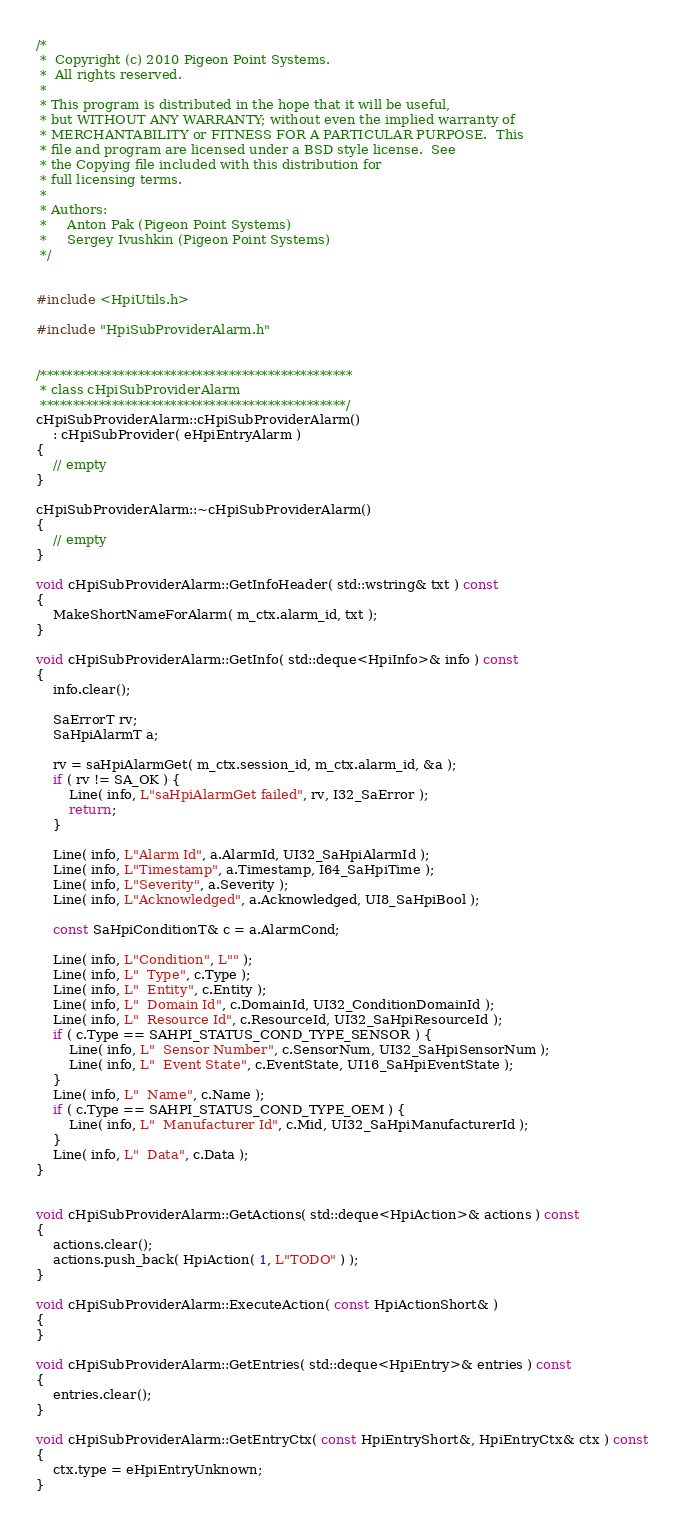<code> <loc_0><loc_0><loc_500><loc_500><_C++_>/*
 *  Copyright (c) 2010 Pigeon Point Systems.
 *  All rights reserved.
 *
 * This program is distributed in the hope that it will be useful,
 * but WITHOUT ANY WARRANTY; without even the implied warranty of
 * MERCHANTABILITY or FITNESS FOR A PARTICULAR PURPOSE.  This
 * file and program are licensed under a BSD style license.  See
 * the Copying file included with this distribution for
 * full licensing terms.
 *
 * Authors:
 *     Anton Pak (Pigeon Point Systems)
 *     Sergey Ivushkin (Pigeon Point Systems)
 */


#include <HpiUtils.h>

#include "HpiSubProviderAlarm.h"


/************************************************
 * class cHpiSubProviderAlarm
 ***********************************************/
cHpiSubProviderAlarm::cHpiSubProviderAlarm()
    : cHpiSubProvider( eHpiEntryAlarm )
{
    // empty
}

cHpiSubProviderAlarm::~cHpiSubProviderAlarm()
{
    // empty
}

void cHpiSubProviderAlarm::GetInfoHeader( std::wstring& txt ) const
{
    MakeShortNameForAlarm( m_ctx.alarm_id, txt );
}

void cHpiSubProviderAlarm::GetInfo( std::deque<HpiInfo>& info ) const
{
    info.clear();

    SaErrorT rv;
    SaHpiAlarmT a;

    rv = saHpiAlarmGet( m_ctx.session_id, m_ctx.alarm_id, &a );
    if ( rv != SA_OK ) {
        Line( info, L"saHpiAlarmGet failed", rv, I32_SaError );
        return;
    }

    Line( info, L"Alarm Id", a.AlarmId, UI32_SaHpiAlarmId );
    Line( info, L"Timestamp", a.Timestamp, I64_SaHpiTime );
    Line( info, L"Severity", a.Severity );
    Line( info, L"Acknowledged", a.Acknowledged, UI8_SaHpiBool );

    const SaHpiConditionT& c = a.AlarmCond;

    Line( info, L"Condition", L"" );
    Line( info, L"  Type", c.Type );
    Line( info, L"  Entity", c.Entity );
    Line( info, L"  Domain Id", c.DomainId, UI32_ConditionDomainId );
    Line( info, L"  Resource Id", c.ResourceId, UI32_SaHpiResourceId );
    if ( c.Type == SAHPI_STATUS_COND_TYPE_SENSOR ) {
        Line( info, L"  Sensor Number", c.SensorNum, UI32_SaHpiSensorNum );
        Line( info, L"  Event State", c.EventState, UI16_SaHpiEventState );
    }
    Line( info, L"  Name", c.Name );
    if ( c.Type == SAHPI_STATUS_COND_TYPE_OEM ) {
        Line( info, L"  Manufacturer Id", c.Mid, UI32_SaHpiManufacturerId );
    }
    Line( info, L"  Data", c.Data );
}


void cHpiSubProviderAlarm::GetActions( std::deque<HpiAction>& actions ) const
{
    actions.clear();
    actions.push_back( HpiAction( 1, L"TODO" ) );
}

void cHpiSubProviderAlarm::ExecuteAction( const HpiActionShort& )
{
}

void cHpiSubProviderAlarm::GetEntries( std::deque<HpiEntry>& entries ) const
{
    entries.clear();
}

void cHpiSubProviderAlarm::GetEntryCtx( const HpiEntryShort&, HpiEntryCtx& ctx ) const
{
    ctx.type = eHpiEntryUnknown;
}

</code> 